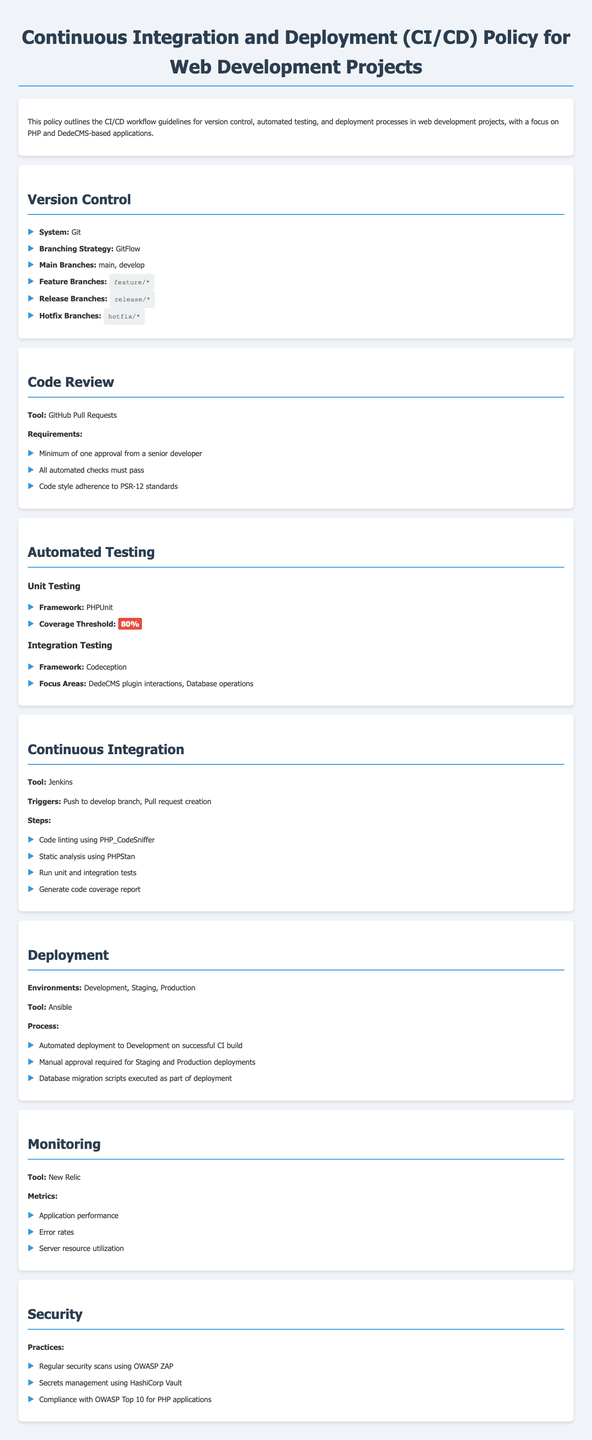What is the version control system used? The document states that the version control system used is Git.
Answer: Git What is the main branching strategy employed? The policy outlines that the branching strategy used is GitFlow.
Answer: GitFlow What is the coverage threshold for unit testing? According to the policy, the coverage threshold for unit testing is specified as 80%.
Answer: 80% Which tool is mentioned for code review? The document indicates that GitHub Pull Requests is the tool designated for code review.
Answer: GitHub Pull Requests What is required for a pull request to be approved? The requirements state that a minimum of one approval from a senior developer is necessary, among other conditions.
Answer: One approval What is the automated deployment tool used? The policy specifies that Ansible is the tool used for automated deployment.
Answer: Ansible What metrics are monitored according to the policy? The document lists application performance, error rates, and server resource utilization as the primary metrics monitored.
Answer: Application performance, error rates, server resource utilization What is the focus area of integration testing? The policy details that DedeCMS plugin interactions and database operations are the focus areas for integration testing.
Answer: DedeCMS plugin interactions, Database operations What security tool is mentioned for scans? The document informs that OWASP ZAP is the tool used for regular security scans.
Answer: OWASP ZAP 